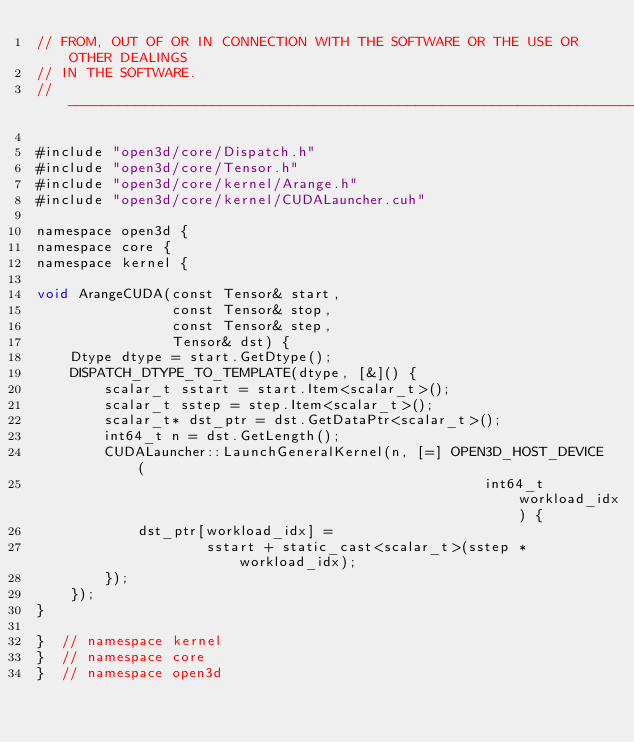Convert code to text. <code><loc_0><loc_0><loc_500><loc_500><_Cuda_>// FROM, OUT OF OR IN CONNECTION WITH THE SOFTWARE OR THE USE OR OTHER DEALINGS
// IN THE SOFTWARE.
// ----------------------------------------------------------------------------

#include "open3d/core/Dispatch.h"
#include "open3d/core/Tensor.h"
#include "open3d/core/kernel/Arange.h"
#include "open3d/core/kernel/CUDALauncher.cuh"

namespace open3d {
namespace core {
namespace kernel {

void ArangeCUDA(const Tensor& start,
                const Tensor& stop,
                const Tensor& step,
                Tensor& dst) {
    Dtype dtype = start.GetDtype();
    DISPATCH_DTYPE_TO_TEMPLATE(dtype, [&]() {
        scalar_t sstart = start.Item<scalar_t>();
        scalar_t sstep = step.Item<scalar_t>();
        scalar_t* dst_ptr = dst.GetDataPtr<scalar_t>();
        int64_t n = dst.GetLength();
        CUDALauncher::LaunchGeneralKernel(n, [=] OPEN3D_HOST_DEVICE(
                                                     int64_t workload_idx) {
            dst_ptr[workload_idx] =
                    sstart + static_cast<scalar_t>(sstep * workload_idx);
        });
    });
}

}  // namespace kernel
}  // namespace core
}  // namespace open3d
</code> 